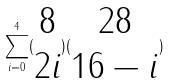Convert formula to latex. <formula><loc_0><loc_0><loc_500><loc_500>\sum _ { i = 0 } ^ { 4 } ( \begin{matrix} 8 \\ 2 i \end{matrix} ) ( \begin{matrix} 2 8 \\ 1 6 - i \end{matrix} )</formula> 